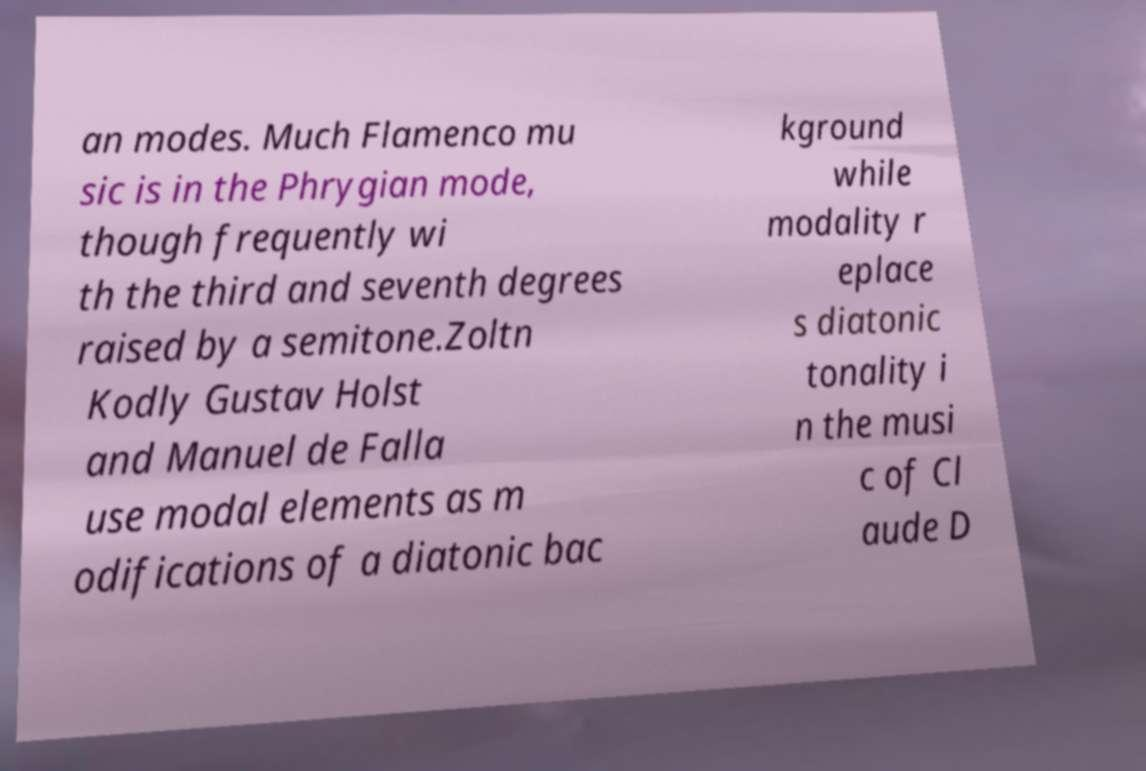For documentation purposes, I need the text within this image transcribed. Could you provide that? an modes. Much Flamenco mu sic is in the Phrygian mode, though frequently wi th the third and seventh degrees raised by a semitone.Zoltn Kodly Gustav Holst and Manuel de Falla use modal elements as m odifications of a diatonic bac kground while modality r eplace s diatonic tonality i n the musi c of Cl aude D 